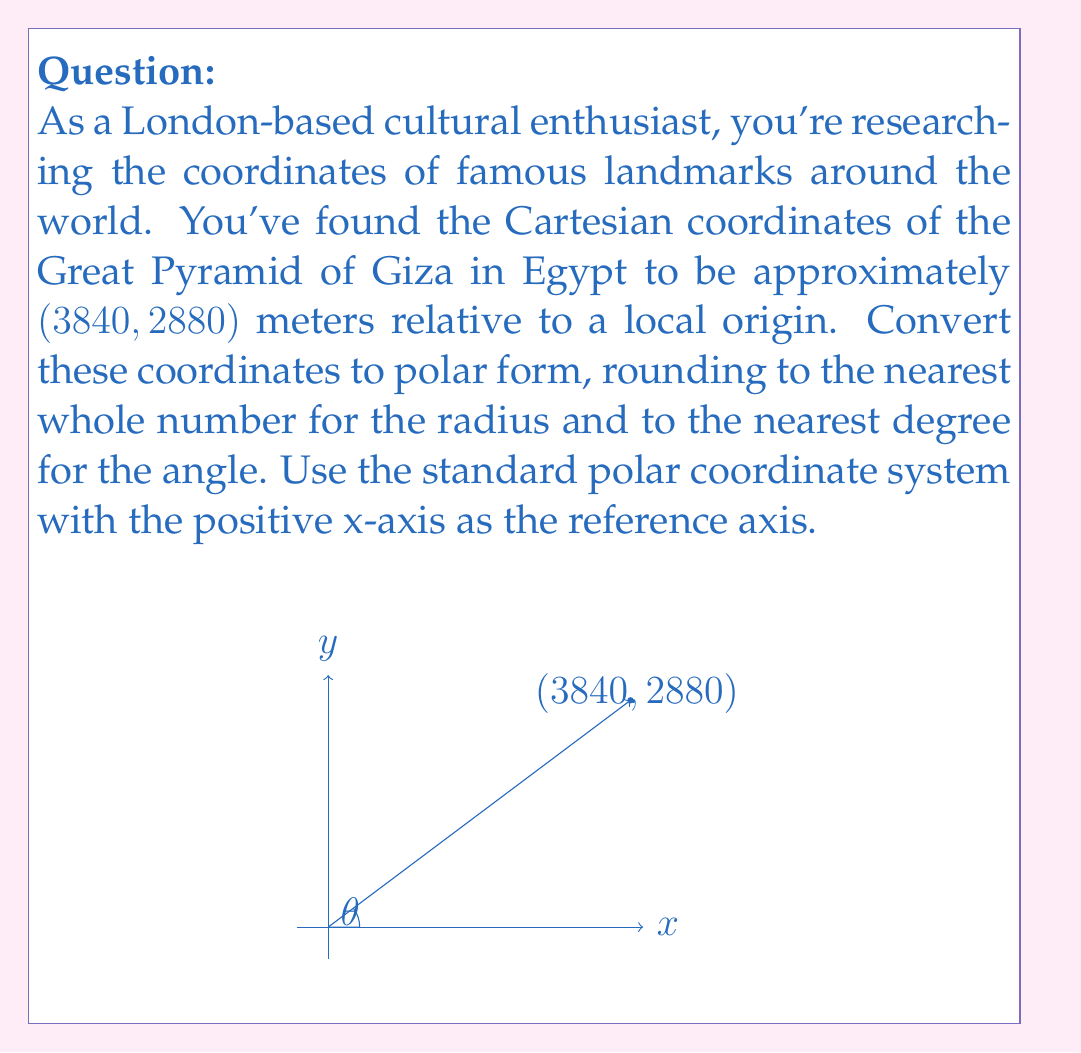Give your solution to this math problem. To convert from Cartesian coordinates $(x, y)$ to polar coordinates $(r, \theta)$, we use the following formulas:

1) $r = \sqrt{x^2 + y^2}$
2) $\theta = \tan^{-1}(\frac{y}{x})$

Let's apply these to our coordinates (3840, 2880):

1) Calculate $r$:
   $$r = \sqrt{3840^2 + 2880^2}$$
   $$r = \sqrt{14,745,600 + 8,294,400}$$
   $$r = \sqrt{23,040,000}$$
   $$r \approx 4800$$

2) Calculate $\theta$:
   $$\theta = \tan^{-1}(\frac{2880}{3840})$$
   $$\theta = \tan^{-1}(0.75)$$
   $$\theta \approx 36.87^\circ$$

Rounding to the nearest whole number for $r$ and the nearest degree for $\theta$, we get:

$r \approx 4800$ meters
$\theta \approx 37^\circ$

Therefore, the polar coordinates are approximately $(4800, 37^\circ)$.
Answer: $(4800, 37^\circ)$ 